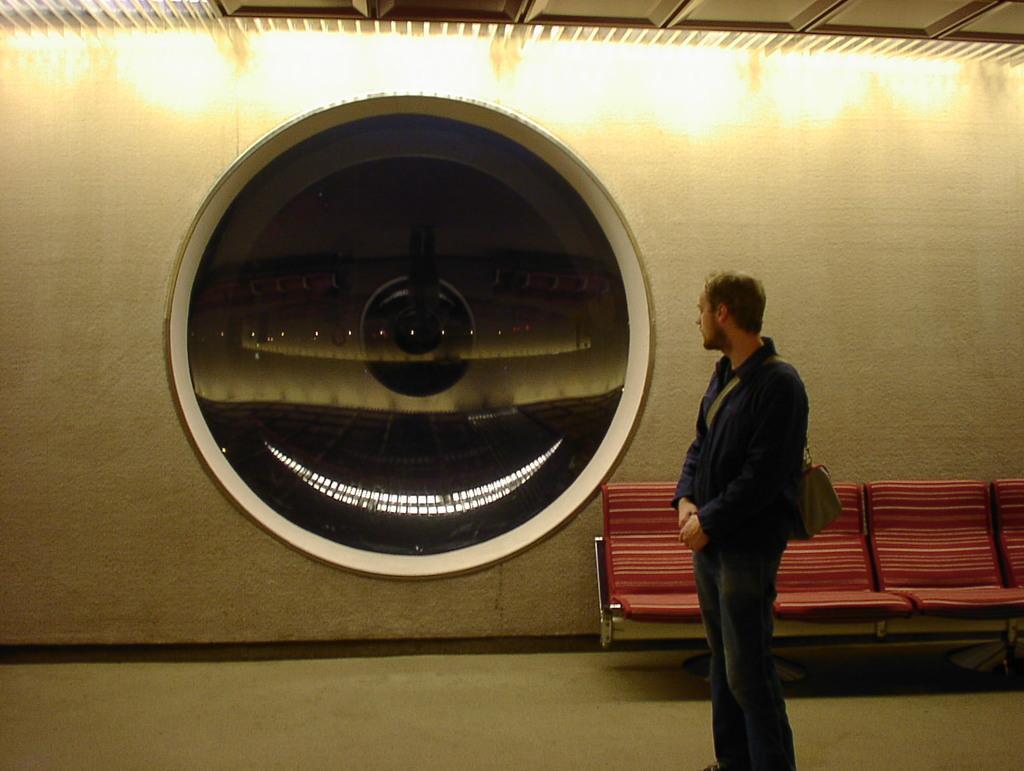In one or two sentences, can you explain what this image depicts? In this image there is a person holding a bag, there are chairs, a glass with some reflections on the wall and the roof. 